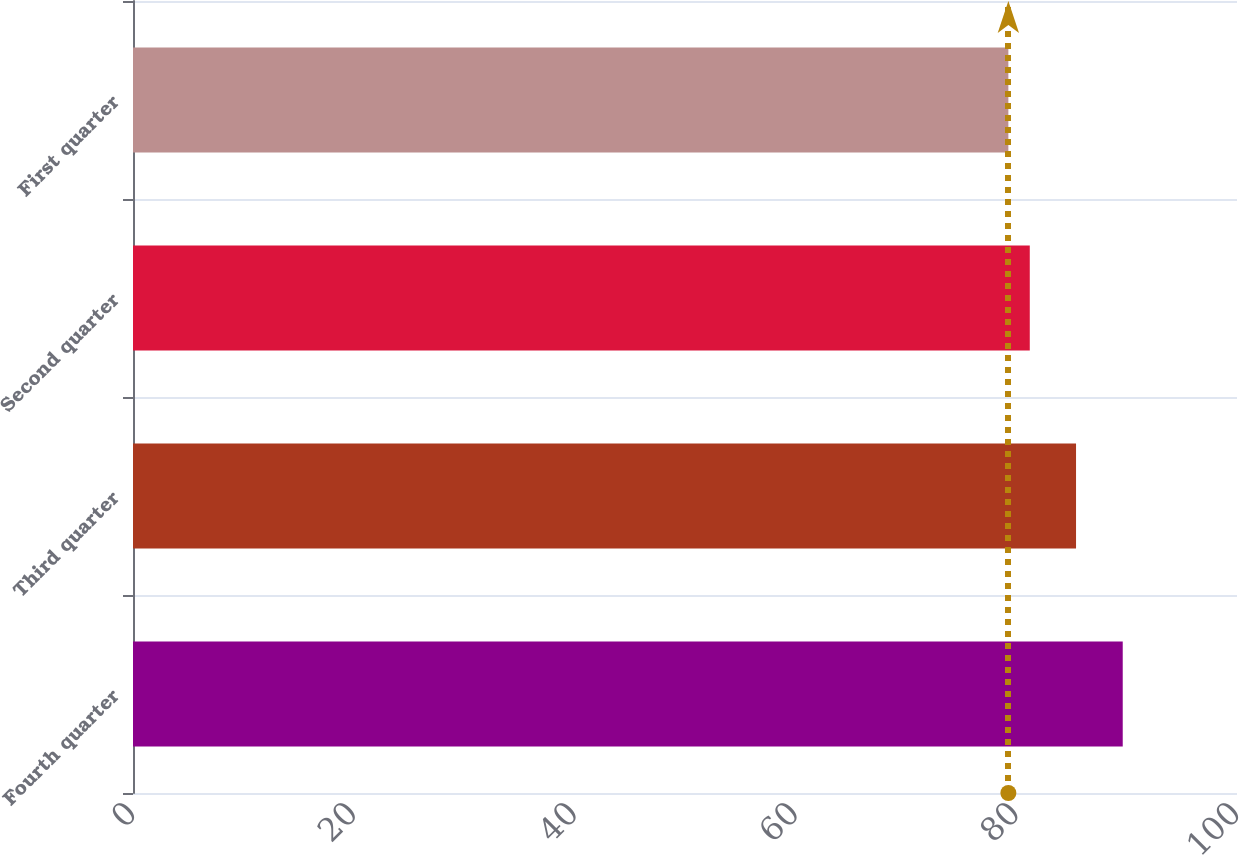Convert chart. <chart><loc_0><loc_0><loc_500><loc_500><bar_chart><fcel>Fourth quarter<fcel>Third quarter<fcel>Second quarter<fcel>First quarter<nl><fcel>89.65<fcel>85.42<fcel>81.23<fcel>79.29<nl></chart> 